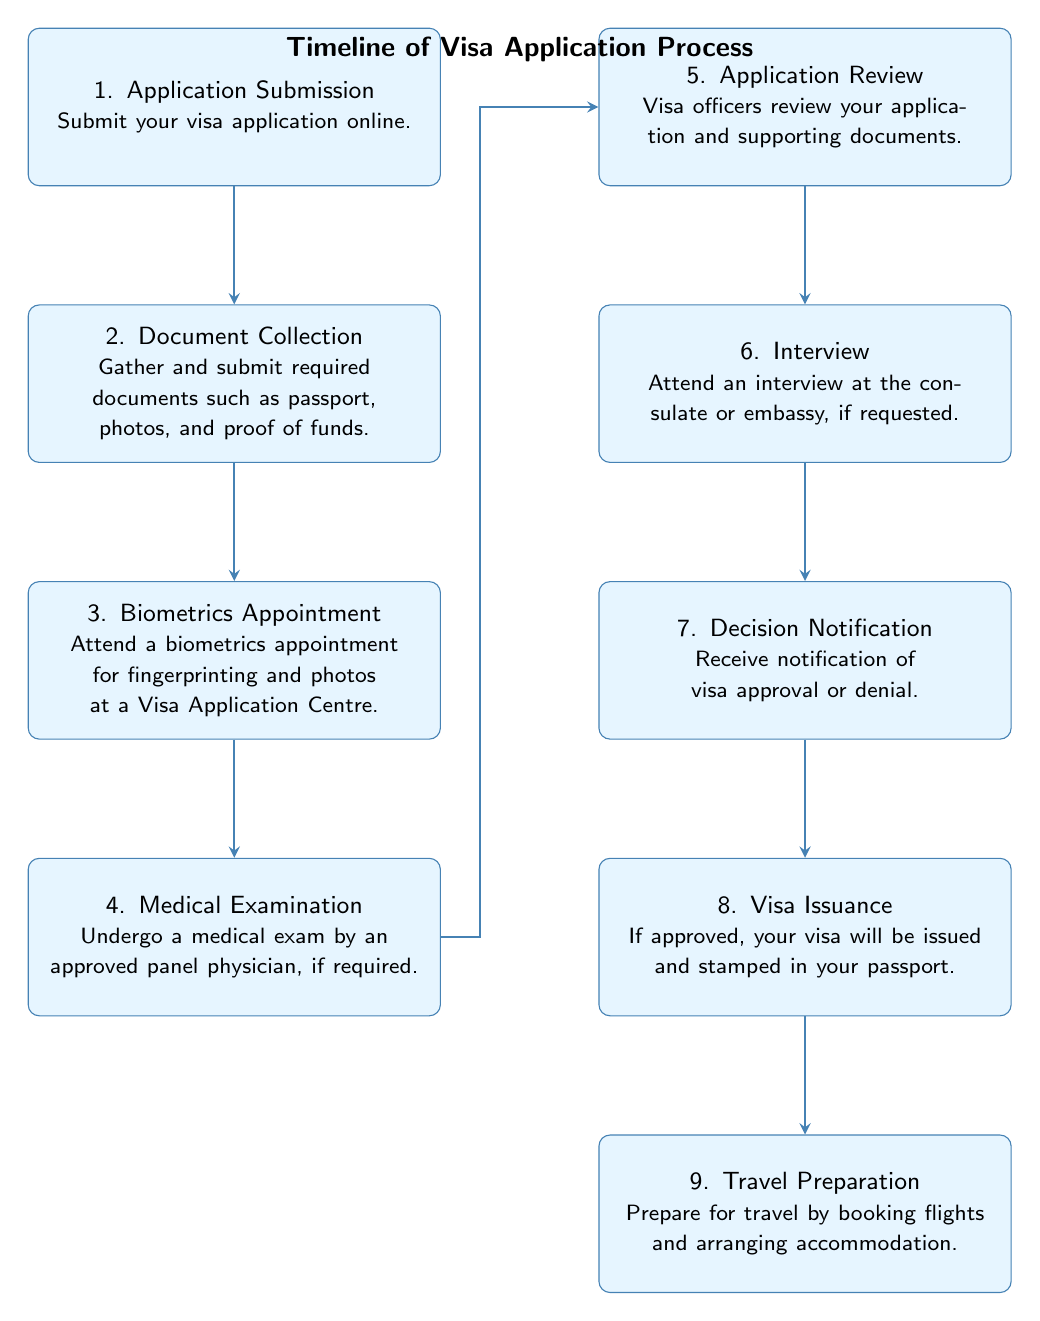What is the first step in the visa application process? The first step is labeled in the diagram as "1. Application Submission." It corresponds to the first box from the top of the timeline.
Answer: Application Submission How many nodes are in the diagram? To find the number of nodes, we can count each step in the visa application process represented in the boxes. There are eight steps in total, which means there are eight nodes.
Answer: 8 What happens after the biometrics appointment? After the "3. Biometrics Appointment," the next step is "4. Medical Examination," which is the box directly below it in the flow.
Answer: Medical Examination What is the last stage of the visa application timeline? The last step in the timeline is "9. Travel Preparation," which is the final box at the bottom of the diagram.
Answer: Travel Preparation Which step requires a visit to a Visa Application Centre? The step that involves a visit to a Visa Application Centre is "3. Biometrics Appointment," as indicated in that box.
Answer: Biometrics Appointment What is the relationship between the "Document Collection" and "Application Review"? "Document Collection" is the second step, and "Application Review" is the fifth step. They are linked directly through the flow of the diagram, showing the progression of the process.
Answer: Application Review What does the fifth step involve? The fifth step, "Application Review," involves visa officers reviewing your application and supporting documents. This is detailed in the description provided within that box.
Answer: Visa officers review How many steps involve an appointment? There are two steps involving an appointment: "3. Biometrics Appointment" and "4. Medical Examination." Therefore, by identifying these stages in the diagram, we conclude there are two that require an appointment.
Answer: 2 What is required before receiving a decision notification? Before receiving a "Decision Notification," the applicant must attend an "Interview," which is the sixth step in the process. This indicates a sequential relationship, indicating the need for the interview prior to the decision.
Answer: Interview 